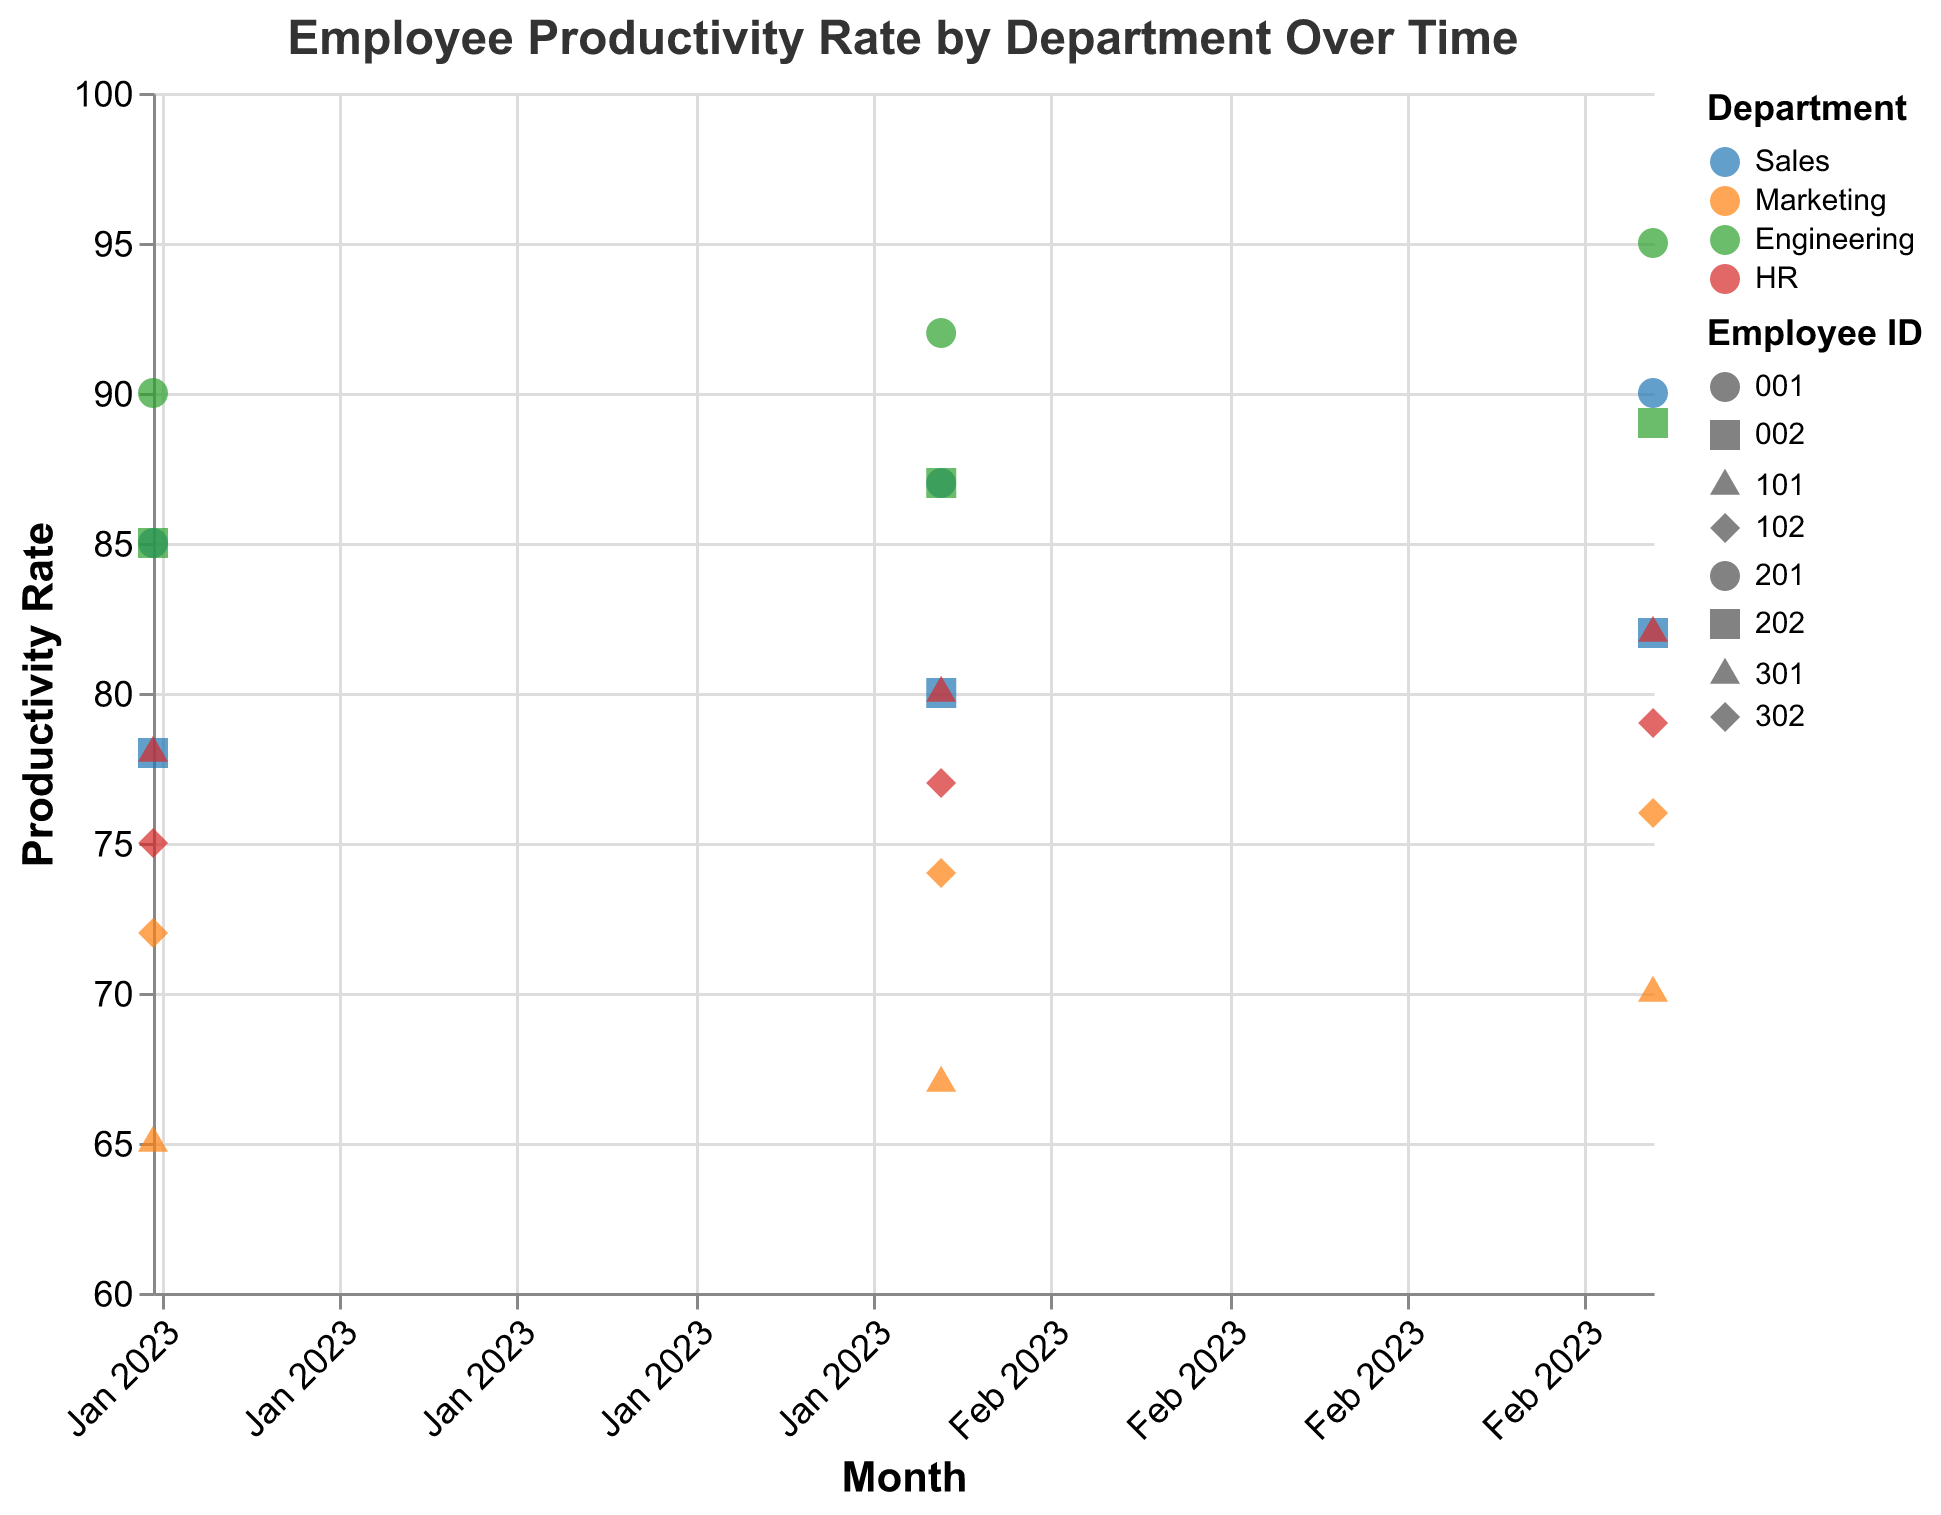What is the title of the plot? The title of the plot is found at the top of the figure and is written in large font for easy identification.
Answer: Employee Productivity Rate by Department Over Time How many departments are represented in the plot? The plot uses different colors to represent different departments. Looking at the color legend, we see four different departments.
Answer: 4 On average, did Employee 001 from Sales improve their productivity rate from January to March 2023? In January, the productivity rate was 85. In February, it was 87, and in March, it reached 90. Calculate the average productivity improvement: (87 - 85) + (90 - 87) = 2 + 3 = 5, divided by 2 months gives an average increase of 2.5.
Answer: Yes, by 2.5 Which department had the highest productivity rate in March 2023? In March 2023, the plot shows the highest productivity rate points. The highest points in March are for Employee 201 in Engineering, with a rate of 95.
Answer: Engineering Compare the productivity rate of Employee 301 and Employee 302 in HR for March 2023. Who had a higher rate? In March 2023, Employee 301 had a productivity rate of 82 and Employee 302 had a rate of 79.
Answer: Employee 301 In which month did Marketing experience the lowest overall productivity rate? By observing the plot, January 2023 shows the lowest productivity points for both Employees 101 and 102 in Marketing, with rates of 65 and 72 respectively.
Answer: January What is the trend of productivity rates for Engineering from January to March 2023? The plot shows increasing points for Engineering: Employee 201 (90 -> 92 -> 95) and Employee 202 (85 -> 87 -> 89), indicating an overall upward trend.
Answer: Increasing Are there any employees whose productivity rate remained constant over the three months? Check each individual’s productivity points for consistency. All employees show changes in productivity rates from month to month.
Answer: No What is the average productivity rate for the Sales department in February 2023? Sales Employee 001 had 87, and Employee 002 had 80. The average is calculated as (87 + 80)/2 = 83.5
Answer: 83.5 